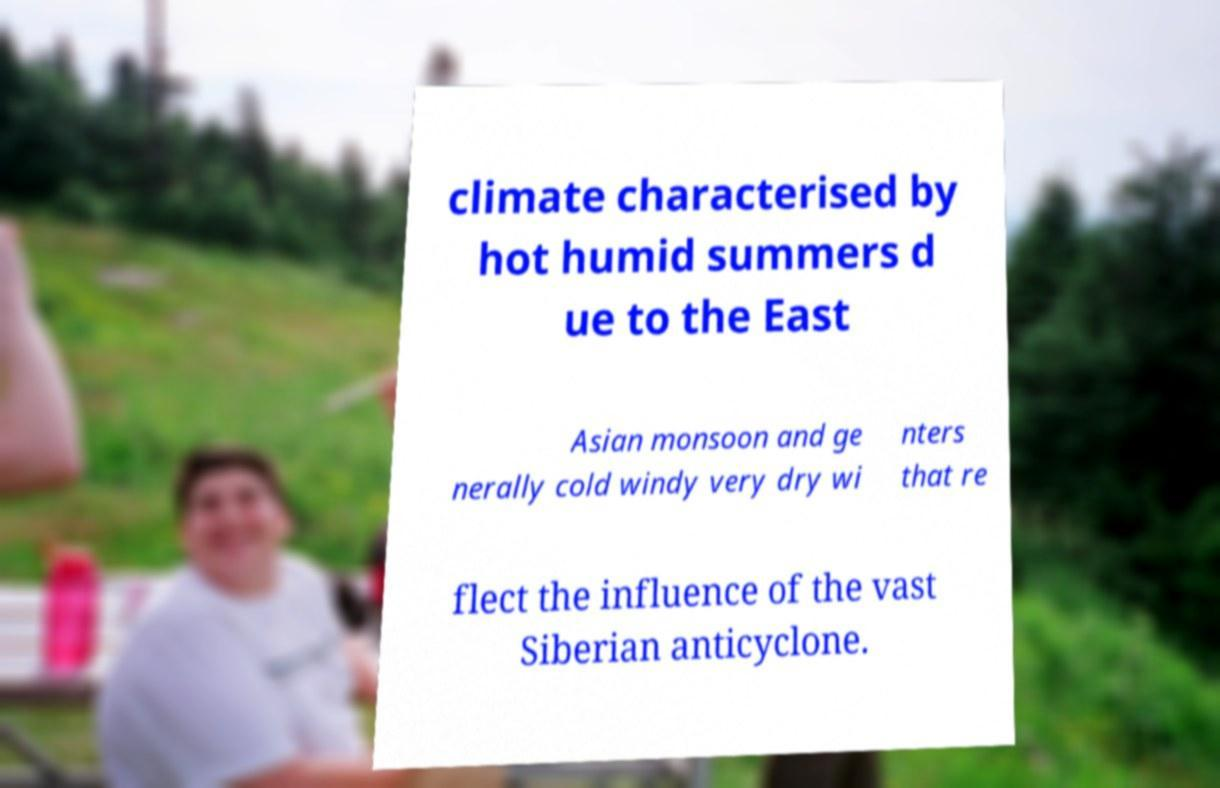There's text embedded in this image that I need extracted. Can you transcribe it verbatim? climate characterised by hot humid summers d ue to the East Asian monsoon and ge nerally cold windy very dry wi nters that re flect the influence of the vast Siberian anticyclone. 